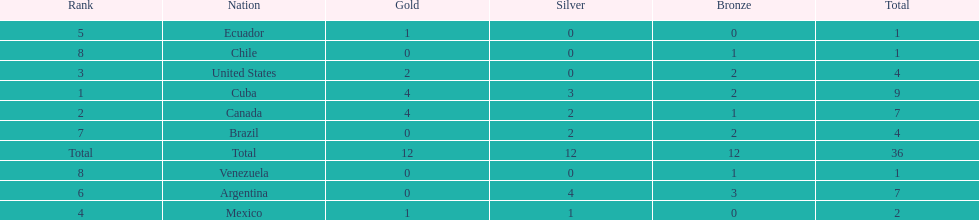Which nation won gold but did not win silver? United States. 